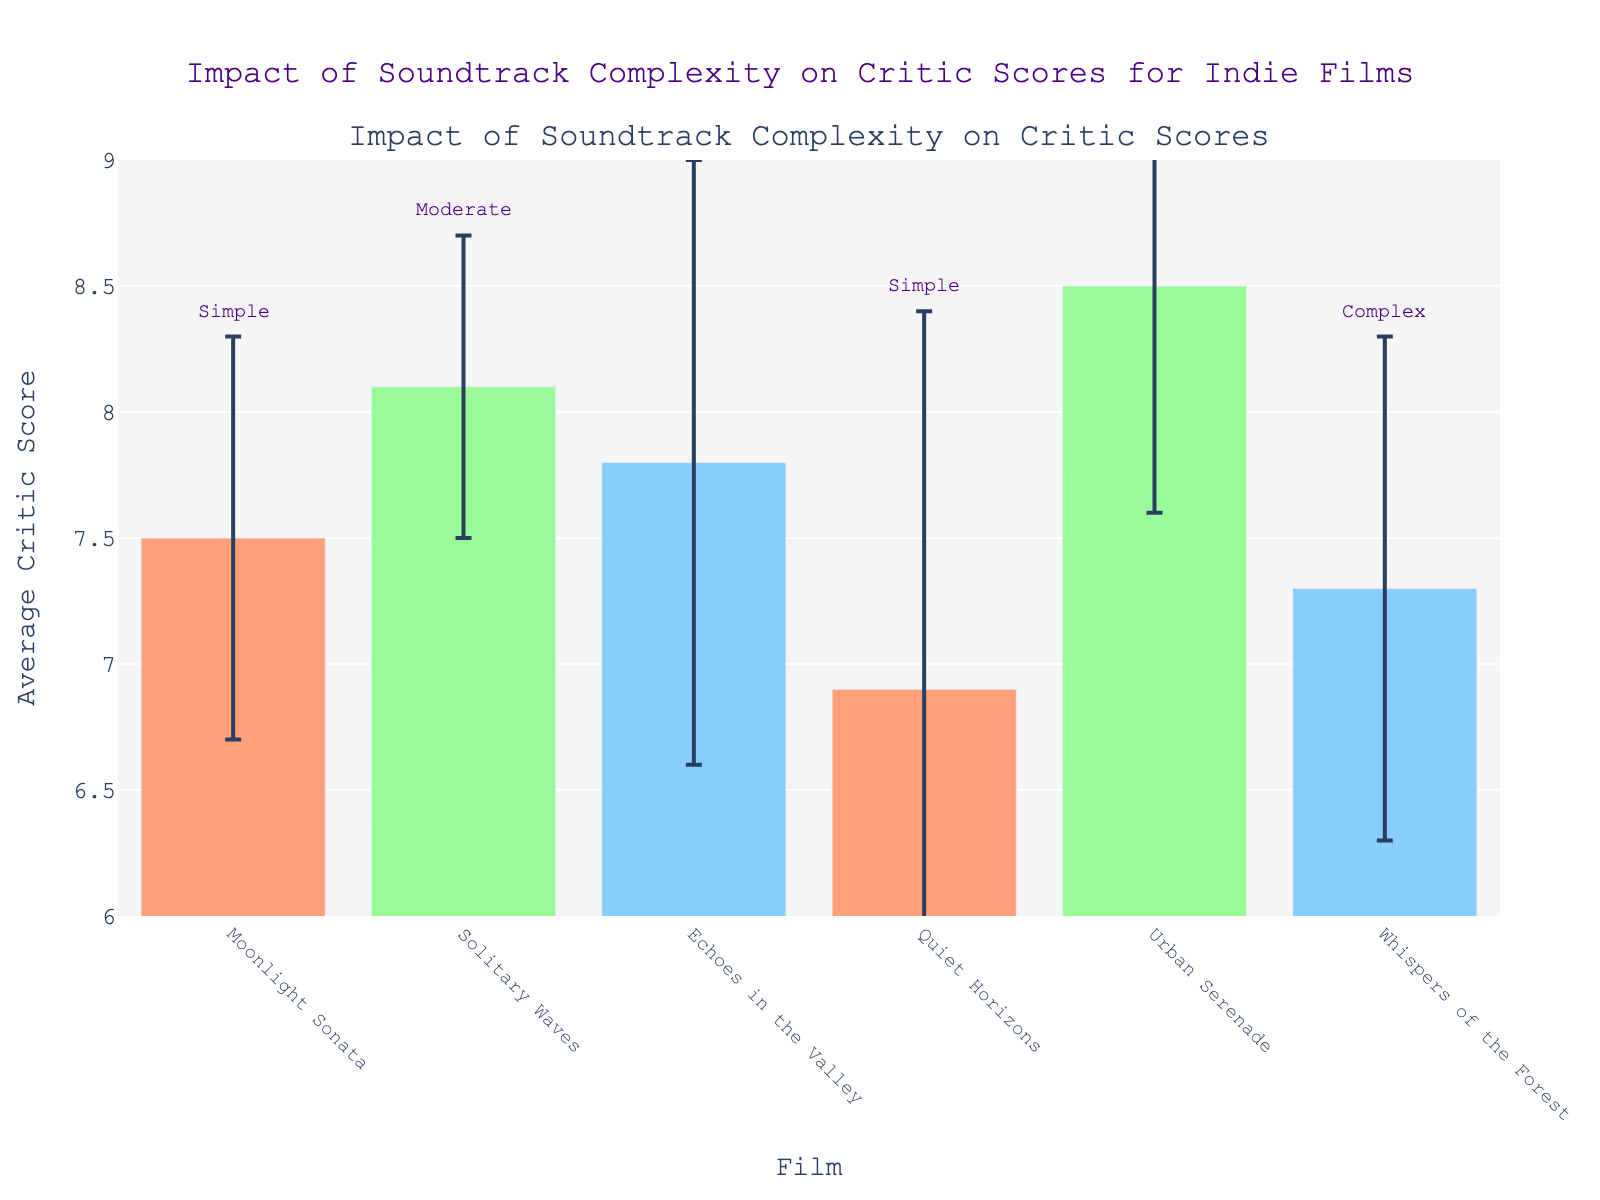How does the soundtrack complexity of "Moonlight Sonata" compare to others? "Moonlight Sonata" has a simple soundtrack complexity. This information is annotated directly above its bar in the chart. Other films have soundtrack complexities that are either moderate or complex, as indicated by the annotations above their respective bars.
Answer: Simple What is the average critic score for "Urban Serenade"? Look for the bar labeled "Urban Serenade". The chart shows an average critic score of 8.5 for this film.
Answer: 8.5 Which film has the highest review spread and what is this value? Look for the film with the tallest error bar. "Quiet Horizons" has the highest review spread with a value of 1.5, as indicated by its error bar length.
Answer: Quiet Horizons, 1.5 What’s the difference in average critic scores between "Solitary Waves" and "Whispers of the Forest"? "Solitary Waves" has an average critic score of 8.1, and "Whispers of the Forest" has a score of 7.3. The difference can be calculated as 8.1 - 7.3 = 0.8.
Answer: 0.8 Which film(s) have a simple soundtrack complexity and what are their average critic scores? "Moonlight Sonata" has an average critic score of 7.5, and "Quiet Horizons" has an average score of 6.9, both with simple soundtrack complexities as annotated above their bars.
Answer: "Moonlight Sonata" - 7.5, "Quiet Horizons" - 6.9 Which film has the lowest average critic score and what is the value? Look for the shortest bar in the chart. "Quiet Horizons" has the lowest average critic score of 6.9.
Answer: Quiet Horizons, 6.9 Which films have a moderate soundtrack complexity and what are their average critic scores and review spreads? "Solitary Waves" and "Urban Serenade" both have moderate soundtrack complexities. "Solitary Waves" has an average critic score of 8.1 with a review spread of 0.6, and "Urban Serenade" has an average score of 8.5 with a review spread of 0.9.
Answer: "Solitary Waves" - 8.1 (0.6), "Urban Serenade" - 8.5 (0.9) How does the average critic score of "Echoes in the Valley" compare to "Whispers of the Forest"? "Echoes in the Valley" has an average critic score of 7.8, while "Whispers of the Forest" has a score of 7.3. "Echoes in the Valley" has a higher score by 0.5 points.
Answer: Echoes in the Valley is higher by 0.5 points Which film has the smallest review spread and how can you determine this from the chart? "Solitary Waves" has the smallest review spread of 0.6, which can be observed from the error bars. It has the shortest error bar on the chart.
Answer: Solitary Waves, 0.6 What is the total average critic score of all films combined? Sum the average critic scores: 7.5 + 8.1 + 7.8 + 6.9 + 8.5 + 7.3 = 46.1
Answer: 46.1 